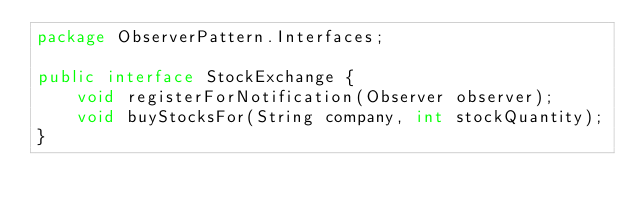<code> <loc_0><loc_0><loc_500><loc_500><_Java_>package ObserverPattern.Interfaces;

public interface StockExchange {
    void registerForNotification(Observer observer);
    void buyStocksFor(String company, int stockQuantity);
}
</code> 